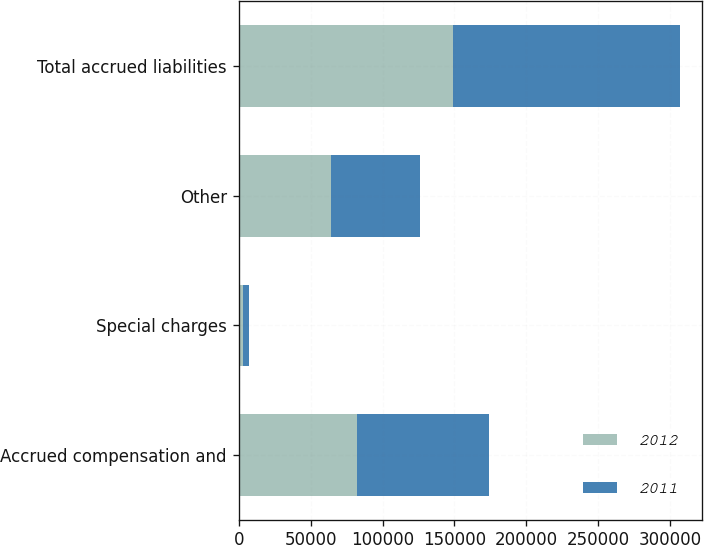Convert chart. <chart><loc_0><loc_0><loc_500><loc_500><stacked_bar_chart><ecel><fcel>Accrued compensation and<fcel>Special charges<fcel>Other<fcel>Total accrued liabilities<nl><fcel>2012<fcel>82027<fcel>2993<fcel>63887<fcel>148907<nl><fcel>2011<fcel>91918<fcel>3876<fcel>61822<fcel>157616<nl></chart> 